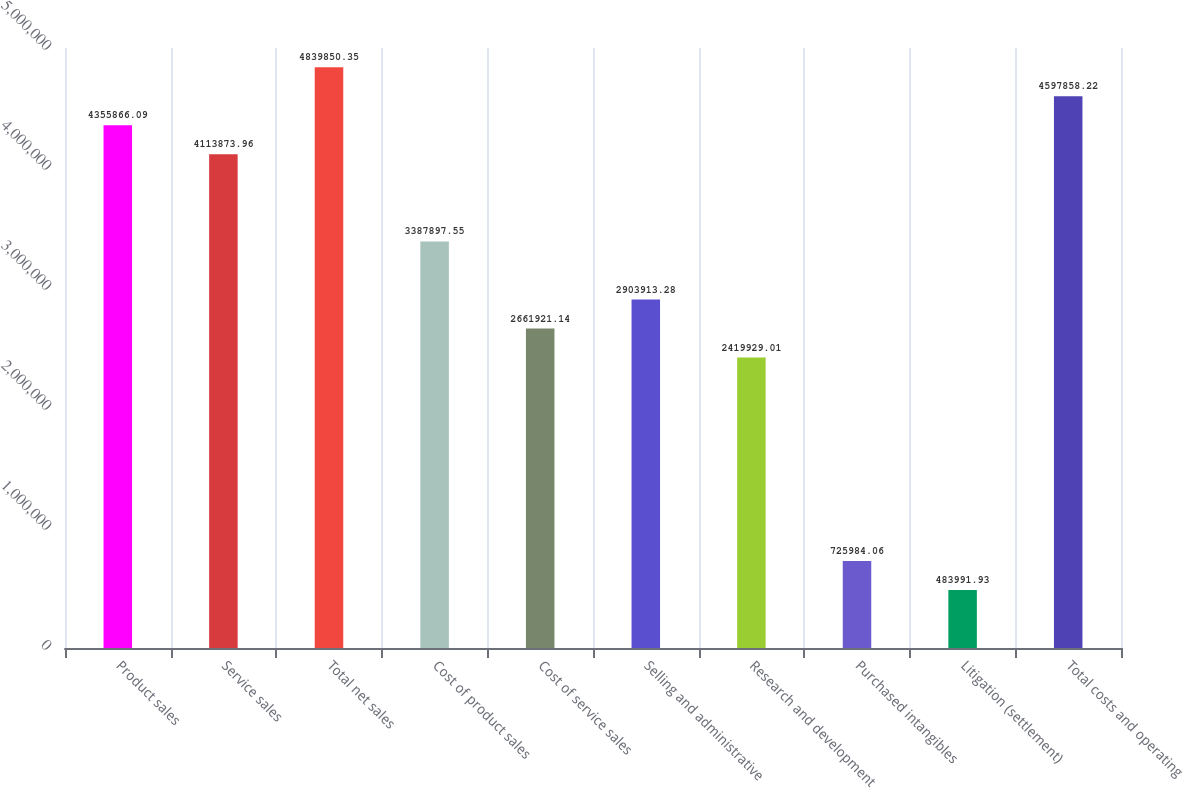Convert chart. <chart><loc_0><loc_0><loc_500><loc_500><bar_chart><fcel>Product sales<fcel>Service sales<fcel>Total net sales<fcel>Cost of product sales<fcel>Cost of service sales<fcel>Selling and administrative<fcel>Research and development<fcel>Purchased intangibles<fcel>Litigation (settlement)<fcel>Total costs and operating<nl><fcel>4.35587e+06<fcel>4.11387e+06<fcel>4.83985e+06<fcel>3.3879e+06<fcel>2.66192e+06<fcel>2.90391e+06<fcel>2.41993e+06<fcel>725984<fcel>483992<fcel>4.59786e+06<nl></chart> 